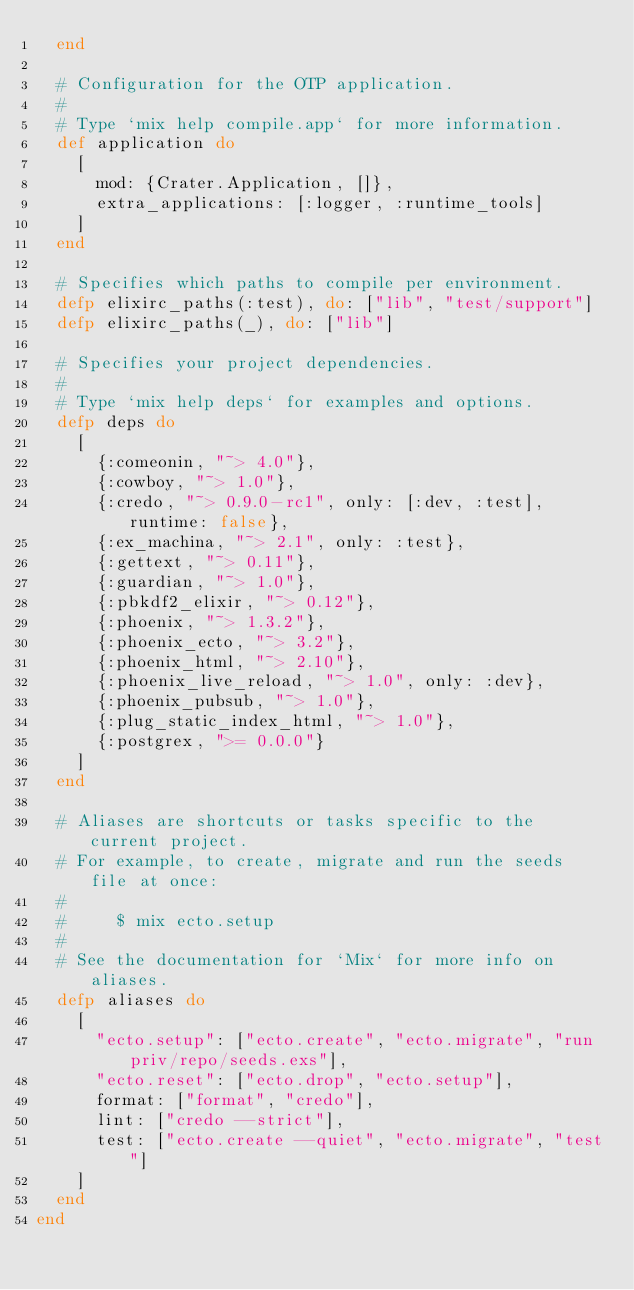Convert code to text. <code><loc_0><loc_0><loc_500><loc_500><_Elixir_>  end

  # Configuration for the OTP application.
  #
  # Type `mix help compile.app` for more information.
  def application do
    [
      mod: {Crater.Application, []},
      extra_applications: [:logger, :runtime_tools]
    ]
  end

  # Specifies which paths to compile per environment.
  defp elixirc_paths(:test), do: ["lib", "test/support"]
  defp elixirc_paths(_), do: ["lib"]

  # Specifies your project dependencies.
  #
  # Type `mix help deps` for examples and options.
  defp deps do
    [
      {:comeonin, "~> 4.0"},
      {:cowboy, "~> 1.0"},
      {:credo, "~> 0.9.0-rc1", only: [:dev, :test], runtime: false},
      {:ex_machina, "~> 2.1", only: :test},
      {:gettext, "~> 0.11"},
      {:guardian, "~> 1.0"},
      {:pbkdf2_elixir, "~> 0.12"},
      {:phoenix, "~> 1.3.2"},
      {:phoenix_ecto, "~> 3.2"},
      {:phoenix_html, "~> 2.10"},
      {:phoenix_live_reload, "~> 1.0", only: :dev},
      {:phoenix_pubsub, "~> 1.0"},
      {:plug_static_index_html, "~> 1.0"},
      {:postgrex, ">= 0.0.0"}
    ]
  end

  # Aliases are shortcuts or tasks specific to the current project.
  # For example, to create, migrate and run the seeds file at once:
  #
  #     $ mix ecto.setup
  #
  # See the documentation for `Mix` for more info on aliases.
  defp aliases do
    [
      "ecto.setup": ["ecto.create", "ecto.migrate", "run priv/repo/seeds.exs"],
      "ecto.reset": ["ecto.drop", "ecto.setup"],
      format: ["format", "credo"],
      lint: ["credo --strict"],
      test: ["ecto.create --quiet", "ecto.migrate", "test"]
    ]
  end
end
</code> 